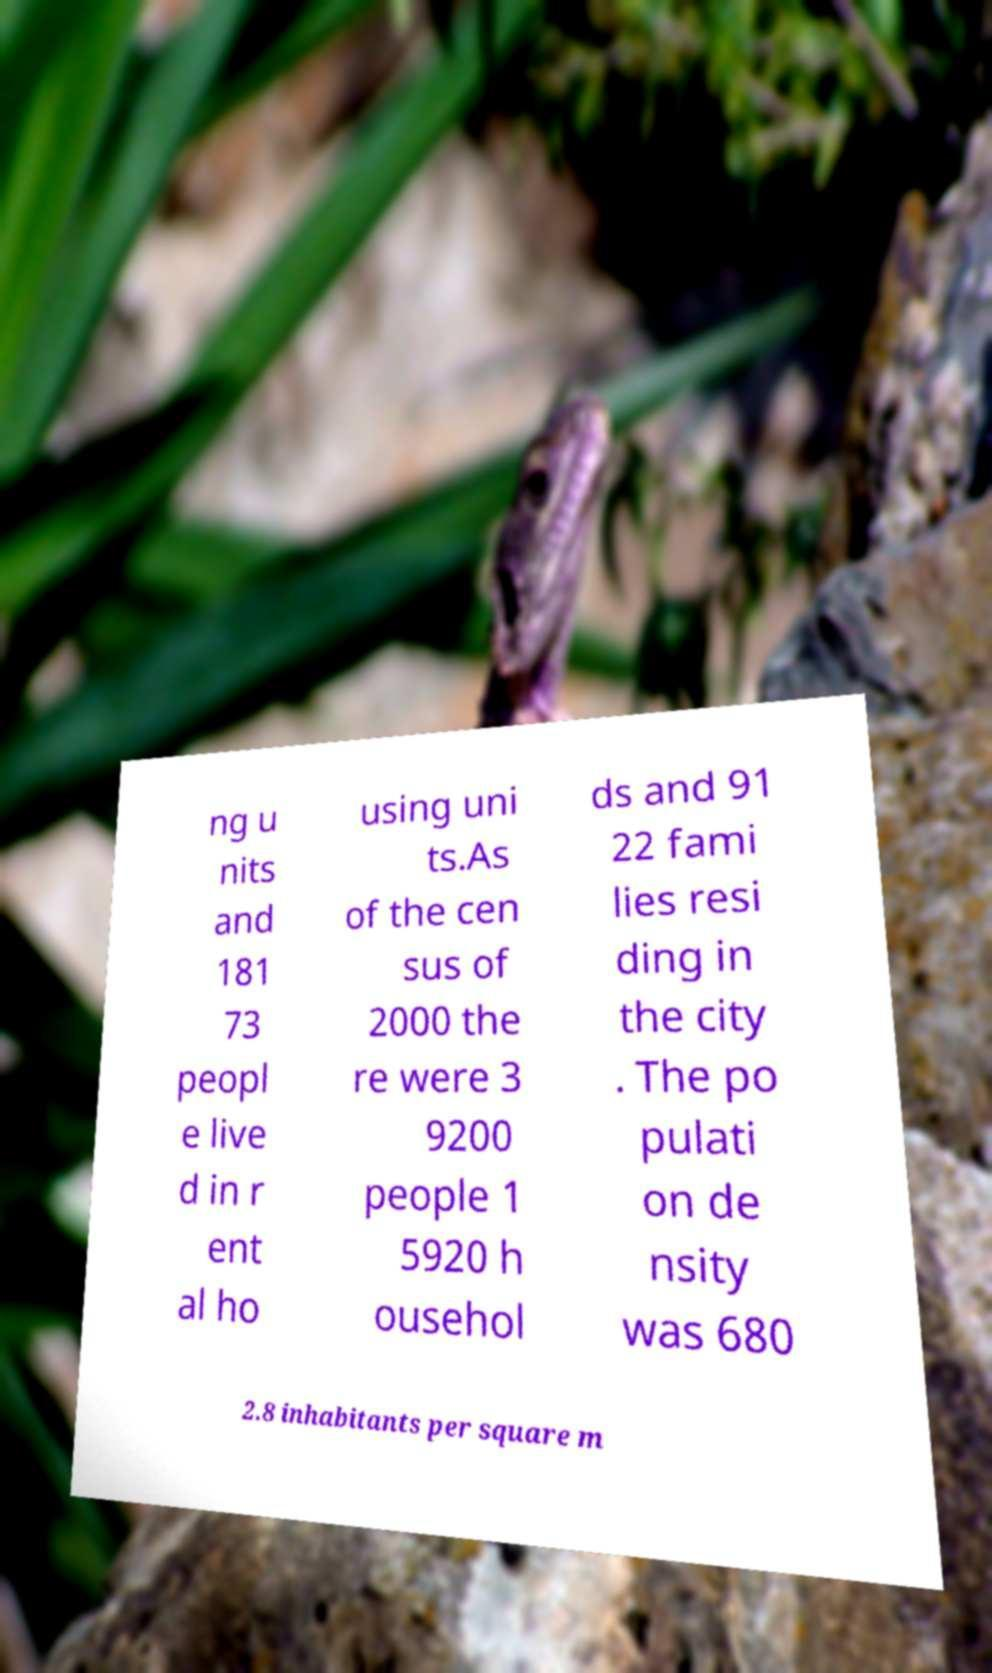Could you assist in decoding the text presented in this image and type it out clearly? ng u nits and 181 73 peopl e live d in r ent al ho using uni ts.As of the cen sus of 2000 the re were 3 9200 people 1 5920 h ousehol ds and 91 22 fami lies resi ding in the city . The po pulati on de nsity was 680 2.8 inhabitants per square m 